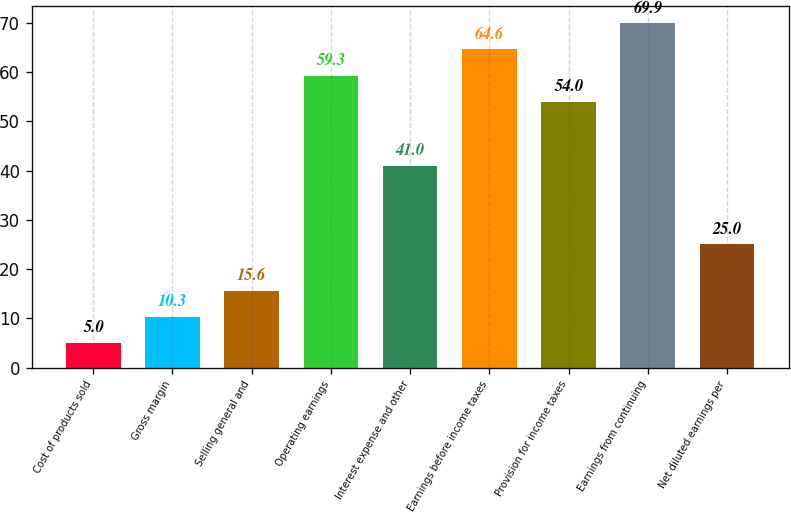Convert chart to OTSL. <chart><loc_0><loc_0><loc_500><loc_500><bar_chart><fcel>Cost of products sold<fcel>Gross margin<fcel>Selling general and<fcel>Operating earnings<fcel>Interest expense and other<fcel>Earnings before income taxes<fcel>Provision for income taxes<fcel>Earnings from continuing<fcel>Net diluted earnings per<nl><fcel>5<fcel>10.3<fcel>15.6<fcel>59.3<fcel>41<fcel>64.6<fcel>54<fcel>69.9<fcel>25<nl></chart> 